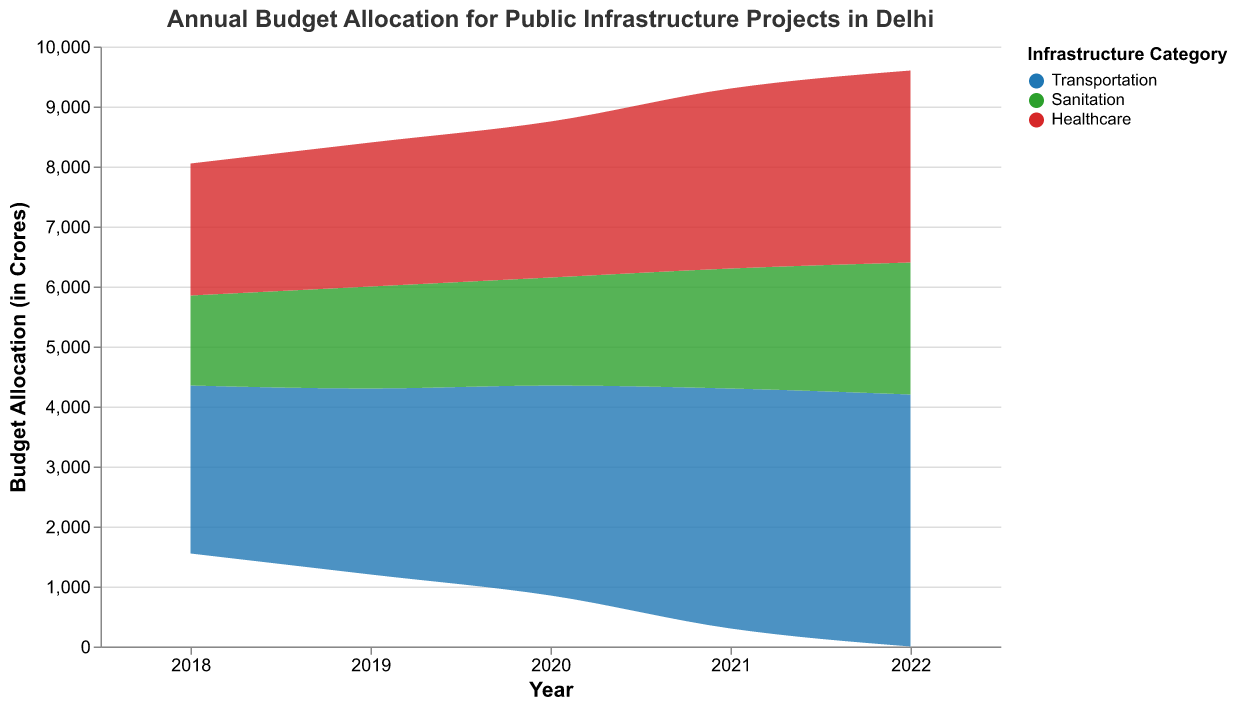What is the title of the graph? The title is displayed at the top of the graph and provides a summary of what the graph represents.
Answer: Annual Budget Allocation for Public Infrastructure Projects in Delhi What are the categories of infrastructure projects shown in the graph? The categories are represented by the different colors in the graph's legend.
Answer: Transportation, Sanitation, Healthcare Which category received the highest budget allocation in 2022? By observing the height of the colored areas at the year 2022, the tallest area represents the category with the highest budget allocation.
Answer: Transportation How does the budget allocation for Sanitation change from 2018 to 2022? Note the height of the green area (representing Sanitation) for each year from 2018 to 2022 and compare them sequentially.
Answer: It increases from 1500 Crores in 2018 to 2200 Crores in 2022 What was the budget allocation for Healthcare in 2020? Look at the height of the red area (representing Healthcare) for the year 2020 in the graph.
Answer: 2600 Crores Which year saw the largest increase in Transportation budget compared to the previous year? Compare the heights of the blue area (representing Transportation) for consecutive years and identify the year with the largest difference.
Answer: 2021 Compare the total budget allocation for all categories in 2018 and 2022. Which year had a higher total allocation? Sum the heights of all three colored areas for the years 2018 and 2022, and compare the totals.
Answer: 2022 How did the budget allocation trend for Healthcare change from 2018 to 2022? Observe the changes in height of the red area (representing Healthcare) from 2018 to 2022.
Answer: It increased steadily Which category had the most stable budget allocation across the years? Identify the category with the least variation in the height of its colored area across all years.
Answer: Healthcare What is the average annual budget allocation for Transportation from 2018 to 2022? Sum the budget allocations for Transportation across all years and divide by the number of years (5).
Answer: 3520 Crores 